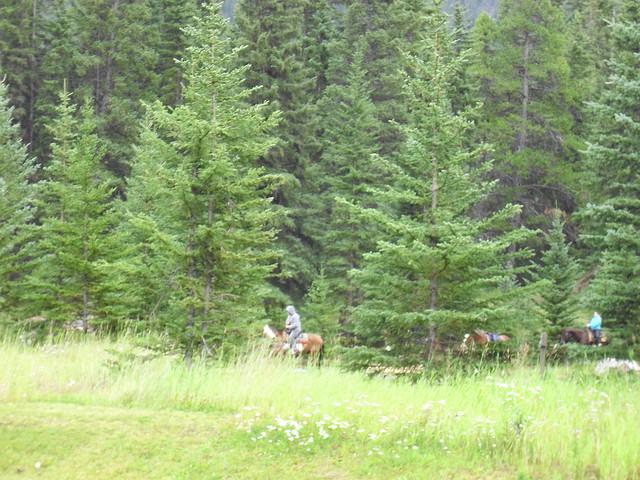What type of animal is in the distance?
Be succinct. Horse. Where might this photo have been taken?
Short answer required. Forest. Is this a natural setting?
Give a very brief answer. Yes. Is this near a forest?
Keep it brief. Yes. 